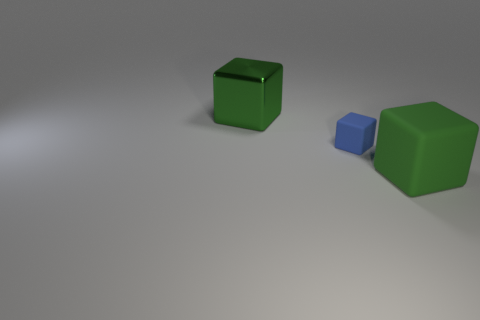What kind of material do the objects look like they're made of? The objects in the image appear to have a matte finish, which suggests that they could be made from a non-reflective material like plastic or painted wood. The surface texture doesn't show any reflections or gloss, which typically characterizes materials with a matte quality. The finish is consistent and smooth, adding to the clean and simple aesthetic of the scene. 